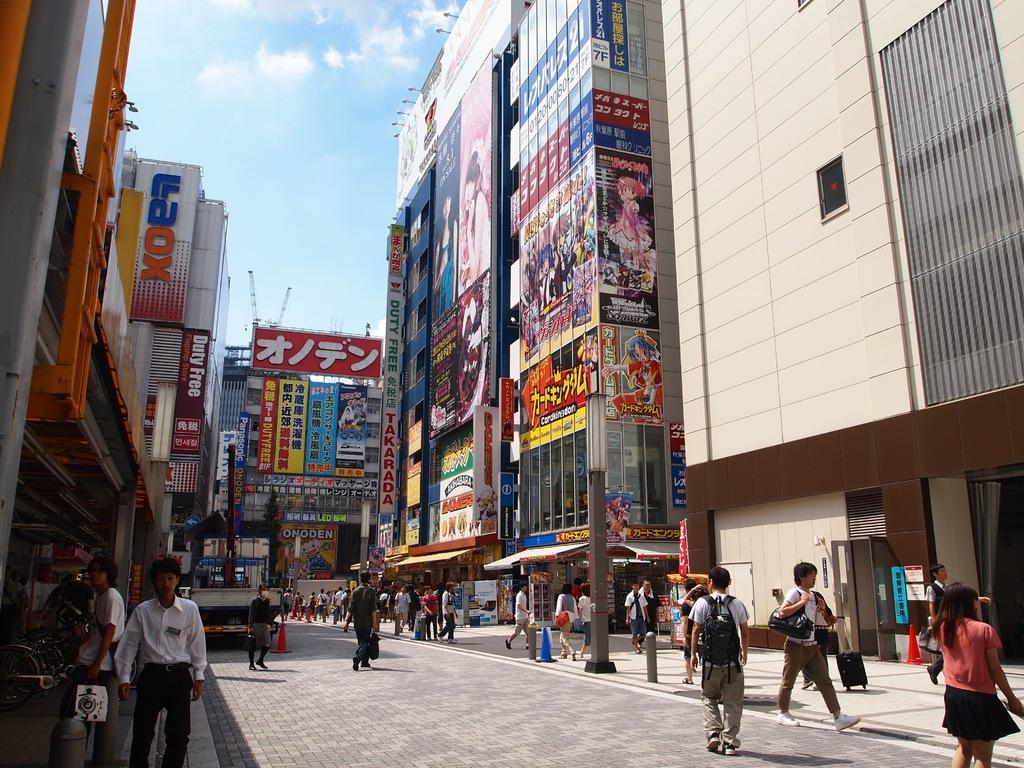What type of surface can be seen in the image? There is ground visible in the image. What are the persons in the image doing? The persons are standing on the ground. What decorative elements are present in the image? There are banners in the image. What type of structures can be seen in the image? There are buildings in the image. What are the tall, thin objects in the image? There are poles in the image. What mode of transportation can be seen in the image? There are bicycles in the image. What is visible in the background of the image? The sky and cranes are visible in the background of the image. What type of silk is being used to make the giraffe's fur in the image? There is no giraffe present in the image, and therefore no silk or fur can be observed. What type of lumber is being used to construct the buildings in the image? The image does not provide information about the materials used to construct the buildings, so it cannot be determined from the image. 